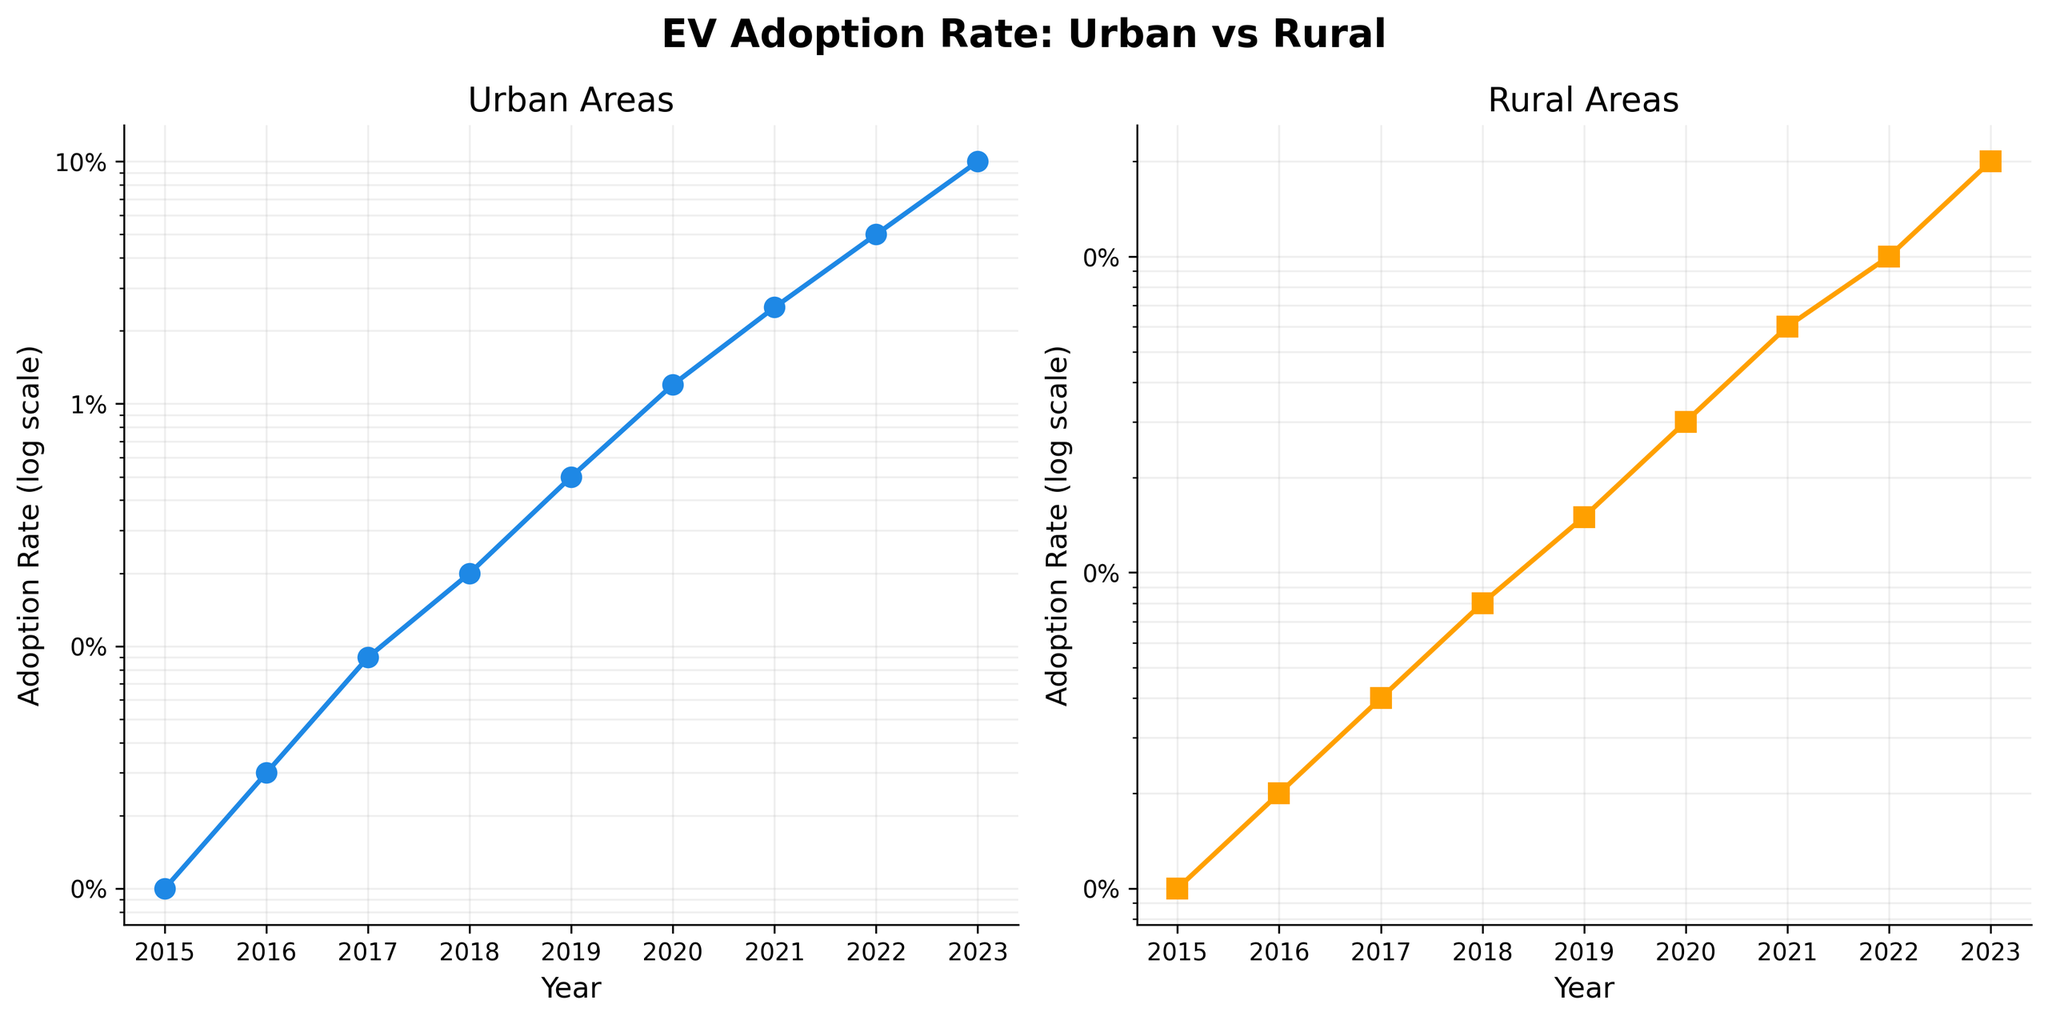What is the title of the figure? Look at the top of the figure where the main title is often located. The title is "EV Adoption Rate: Urban vs Rural".
Answer: "EV Adoption Rate: Urban vs Rural" What are the colors used for the Urban and Rural plots? The Urban plot uses a blue color, and the Rural plot uses an orange color. These distinctions can be seen in the lines and markers of the respective plots.
Answer: Blue for Urban, Orange for Rural What are the adoption rates for Urban areas in 2017? Locate the data point on the Urban plot for the year 2017. The adoption rate at this point is 0.0009.
Answer: 0.0009 How does the Rural EV adoption rate in 2023 compare to the Urban EV adoption rate in 2016? Find the data values for Rural in 2023 (0.002) and Urban in 2016 (0.0003). Compare these two values. Urban EV adoption rate in 2016 is less than Rural EV adoption rate in 2023.
Answer: Rural 2023 > Urban 2016 Between which consecutive years did Urban areas experience the greatest increase in EV adoption rate? Examine the differences between each pair of consecutive years in the Urban plot. Between 2021 and 2022, the adoption rate increases from 0.025 to 0.05, which is the largest jump (0.025).
Answer: 2021 to 2022 What is the shape of the markers used in the Rural plot? Look at the symbols on the Rural plot. The markers are squares.
Answer: Squares How much higher is the Urban EV adoption rate compared to the Rural EV adoption rate in 2020? Find the adoption rates in 2020 for Urban (0.012) and Rural (0.0003). Calculate the difference: 0.012 - 0.0003 = 0.0117.
Answer: 0.0117 What trend is visible in both plots over the years? Observe the general direction of the data points from 2015 to 2023. Both Urban and Rural adoption rates show an increasing trend over the years.
Answer: Increasing trend What is the Urban EV adoption rate in the year when it first exceeds 0.01? Check the data points in the Urban plot to identify the first year the rate exceeds 0.01. In 2020, the rate is 0.012.
Answer: 0.012 What is the ratio of the Urban EV adoption rate to the Rural EV adoption rate in 2022? Divide the Urban adoption rate by the Rural adoption rate in 2022: 0.05 / 0.001 = 50.
Answer: 50 How many data points are there in each subplot? Count the data points along each plot line in both subplots. Both subplots have 9 data points.
Answer: 9 